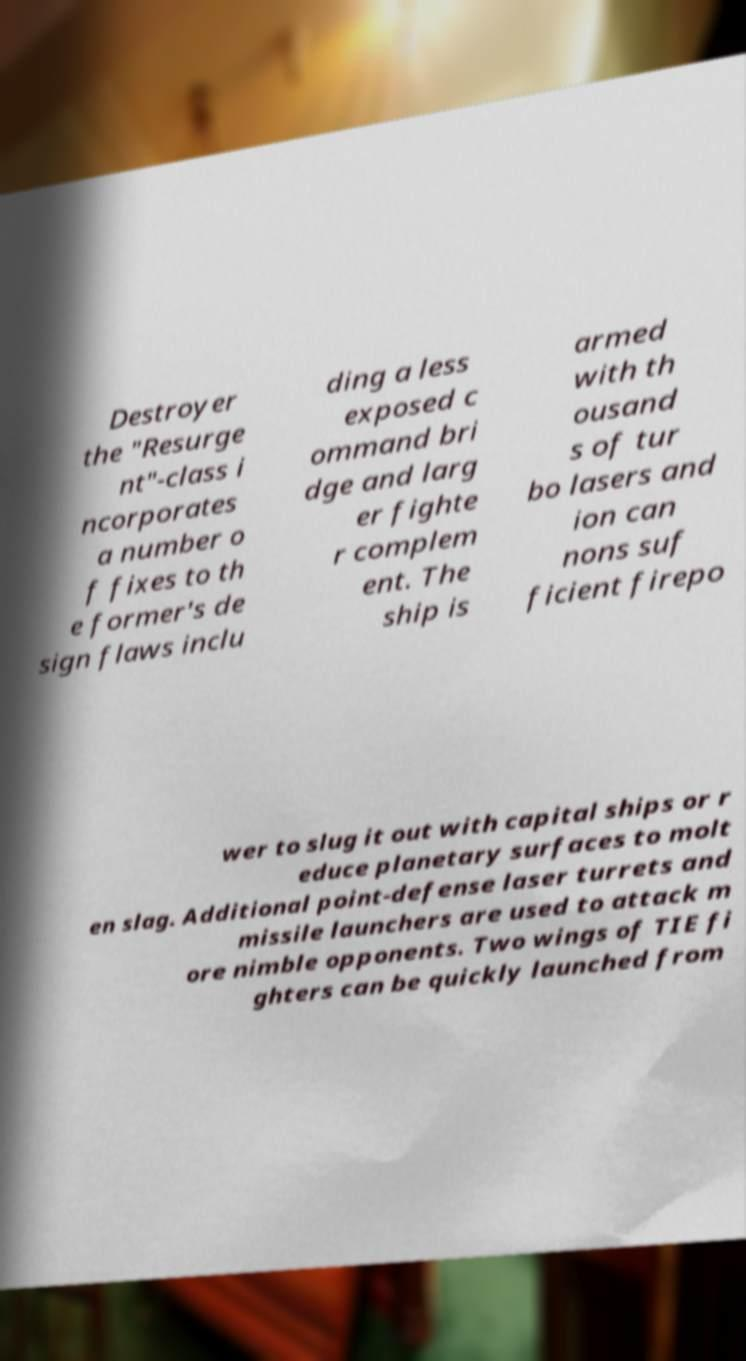There's text embedded in this image that I need extracted. Can you transcribe it verbatim? Destroyer the "Resurge nt"-class i ncorporates a number o f fixes to th e former's de sign flaws inclu ding a less exposed c ommand bri dge and larg er fighte r complem ent. The ship is armed with th ousand s of tur bo lasers and ion can nons suf ficient firepo wer to slug it out with capital ships or r educe planetary surfaces to molt en slag. Additional point-defense laser turrets and missile launchers are used to attack m ore nimble opponents. Two wings of TIE fi ghters can be quickly launched from 